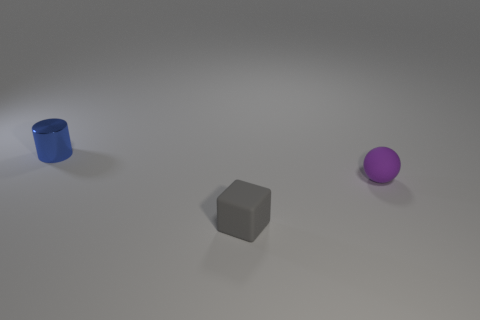Add 2 small brown metallic cylinders. How many objects exist? 5 Subtract all blocks. How many objects are left? 2 Subtract 1 cylinders. How many cylinders are left? 0 Subtract 0 green cylinders. How many objects are left? 3 Subtract all red spheres. Subtract all purple blocks. How many spheres are left? 1 Subtract all small purple rubber balls. Subtract all purple objects. How many objects are left? 1 Add 2 purple spheres. How many purple spheres are left? 3 Add 1 tiny red metal things. How many tiny red metal things exist? 1 